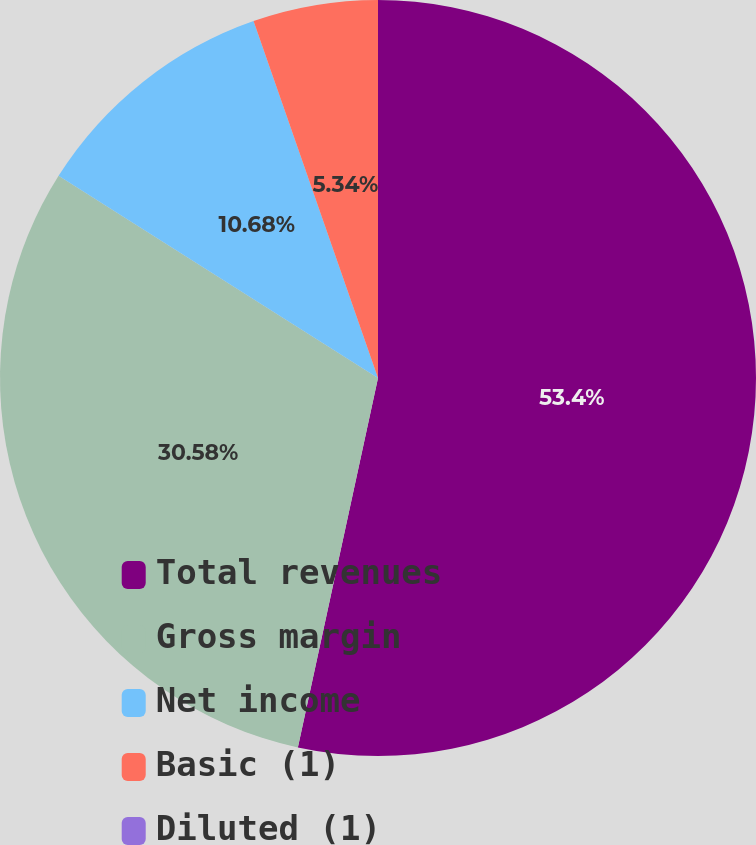Convert chart to OTSL. <chart><loc_0><loc_0><loc_500><loc_500><pie_chart><fcel>Total revenues<fcel>Gross margin<fcel>Net income<fcel>Basic (1)<fcel>Diluted (1)<nl><fcel>53.4%<fcel>30.58%<fcel>10.68%<fcel>5.34%<fcel>0.0%<nl></chart> 